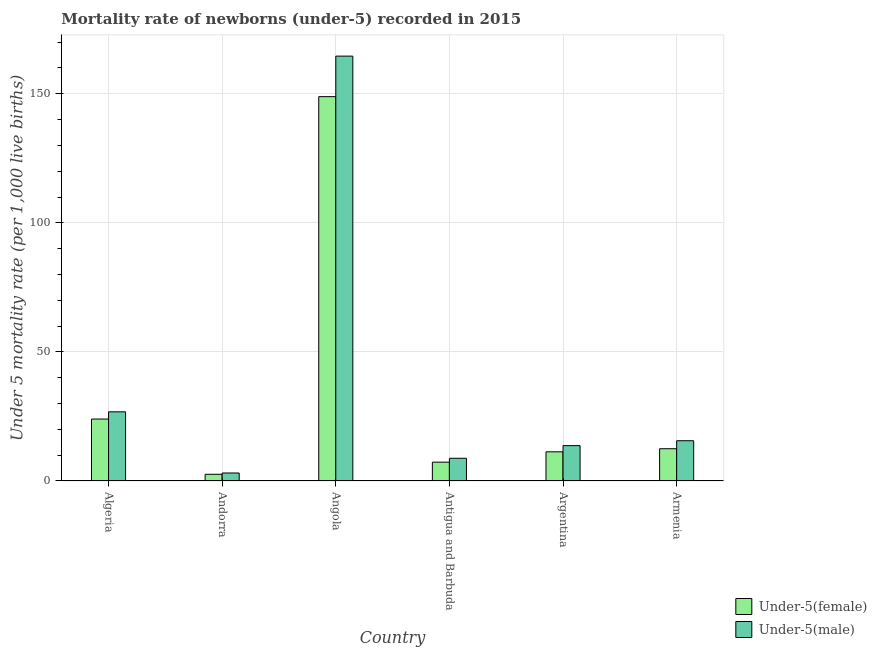Are the number of bars per tick equal to the number of legend labels?
Provide a short and direct response. Yes. Are the number of bars on each tick of the X-axis equal?
Your answer should be compact. Yes. How many bars are there on the 4th tick from the right?
Give a very brief answer. 2. What is the label of the 6th group of bars from the left?
Keep it short and to the point. Armenia. What is the under-5 female mortality rate in Angola?
Your response must be concise. 148.9. Across all countries, what is the maximum under-5 male mortality rate?
Your answer should be compact. 164.6. In which country was the under-5 male mortality rate maximum?
Ensure brevity in your answer.  Angola. In which country was the under-5 female mortality rate minimum?
Your response must be concise. Andorra. What is the total under-5 female mortality rate in the graph?
Your response must be concise. 206.6. What is the difference between the under-5 female mortality rate in Antigua and Barbuda and the under-5 male mortality rate in Andorra?
Your answer should be very brief. 4.2. What is the average under-5 male mortality rate per country?
Your response must be concise. 38.77. What is the difference between the under-5 female mortality rate and under-5 male mortality rate in Armenia?
Ensure brevity in your answer.  -3.1. What is the ratio of the under-5 female mortality rate in Algeria to that in Angola?
Offer a very short reply. 0.16. What is the difference between the highest and the second highest under-5 male mortality rate?
Offer a terse response. 137.8. What is the difference between the highest and the lowest under-5 female mortality rate?
Offer a terse response. 146.3. What does the 2nd bar from the left in Antigua and Barbuda represents?
Give a very brief answer. Under-5(male). What does the 2nd bar from the right in Antigua and Barbuda represents?
Offer a terse response. Under-5(female). Are all the bars in the graph horizontal?
Offer a terse response. No. What is the difference between two consecutive major ticks on the Y-axis?
Keep it short and to the point. 50. Are the values on the major ticks of Y-axis written in scientific E-notation?
Offer a very short reply. No. How many legend labels are there?
Ensure brevity in your answer.  2. What is the title of the graph?
Your answer should be compact. Mortality rate of newborns (under-5) recorded in 2015. What is the label or title of the X-axis?
Your answer should be compact. Country. What is the label or title of the Y-axis?
Keep it short and to the point. Under 5 mortality rate (per 1,0 live births). What is the Under 5 mortality rate (per 1,000 live births) of Under-5(female) in Algeria?
Provide a succinct answer. 24. What is the Under 5 mortality rate (per 1,000 live births) of Under-5(male) in Algeria?
Offer a very short reply. 26.8. What is the Under 5 mortality rate (per 1,000 live births) in Under-5(female) in Andorra?
Offer a terse response. 2.6. What is the Under 5 mortality rate (per 1,000 live births) in Under-5(female) in Angola?
Provide a short and direct response. 148.9. What is the Under 5 mortality rate (per 1,000 live births) of Under-5(male) in Angola?
Give a very brief answer. 164.6. What is the Under 5 mortality rate (per 1,000 live births) in Under-5(female) in Antigua and Barbuda?
Make the answer very short. 7.3. Across all countries, what is the maximum Under 5 mortality rate (per 1,000 live births) of Under-5(female)?
Provide a succinct answer. 148.9. Across all countries, what is the maximum Under 5 mortality rate (per 1,000 live births) of Under-5(male)?
Make the answer very short. 164.6. Across all countries, what is the minimum Under 5 mortality rate (per 1,000 live births) in Under-5(female)?
Provide a succinct answer. 2.6. Across all countries, what is the minimum Under 5 mortality rate (per 1,000 live births) of Under-5(male)?
Keep it short and to the point. 3.1. What is the total Under 5 mortality rate (per 1,000 live births) in Under-5(female) in the graph?
Your response must be concise. 206.6. What is the total Under 5 mortality rate (per 1,000 live births) in Under-5(male) in the graph?
Your answer should be compact. 232.6. What is the difference between the Under 5 mortality rate (per 1,000 live births) in Under-5(female) in Algeria and that in Andorra?
Your response must be concise. 21.4. What is the difference between the Under 5 mortality rate (per 1,000 live births) in Under-5(male) in Algeria and that in Andorra?
Keep it short and to the point. 23.7. What is the difference between the Under 5 mortality rate (per 1,000 live births) of Under-5(female) in Algeria and that in Angola?
Your response must be concise. -124.9. What is the difference between the Under 5 mortality rate (per 1,000 live births) in Under-5(male) in Algeria and that in Angola?
Offer a terse response. -137.8. What is the difference between the Under 5 mortality rate (per 1,000 live births) of Under-5(male) in Algeria and that in Argentina?
Offer a terse response. 13.1. What is the difference between the Under 5 mortality rate (per 1,000 live births) of Under-5(female) in Algeria and that in Armenia?
Keep it short and to the point. 11.5. What is the difference between the Under 5 mortality rate (per 1,000 live births) in Under-5(female) in Andorra and that in Angola?
Your answer should be very brief. -146.3. What is the difference between the Under 5 mortality rate (per 1,000 live births) in Under-5(male) in Andorra and that in Angola?
Make the answer very short. -161.5. What is the difference between the Under 5 mortality rate (per 1,000 live births) of Under-5(female) in Andorra and that in Antigua and Barbuda?
Offer a very short reply. -4.7. What is the difference between the Under 5 mortality rate (per 1,000 live births) in Under-5(male) in Andorra and that in Antigua and Barbuda?
Your answer should be very brief. -5.7. What is the difference between the Under 5 mortality rate (per 1,000 live births) of Under-5(female) in Andorra and that in Armenia?
Offer a terse response. -9.9. What is the difference between the Under 5 mortality rate (per 1,000 live births) in Under-5(male) in Andorra and that in Armenia?
Ensure brevity in your answer.  -12.5. What is the difference between the Under 5 mortality rate (per 1,000 live births) of Under-5(female) in Angola and that in Antigua and Barbuda?
Your response must be concise. 141.6. What is the difference between the Under 5 mortality rate (per 1,000 live births) of Under-5(male) in Angola and that in Antigua and Barbuda?
Ensure brevity in your answer.  155.8. What is the difference between the Under 5 mortality rate (per 1,000 live births) in Under-5(female) in Angola and that in Argentina?
Provide a short and direct response. 137.6. What is the difference between the Under 5 mortality rate (per 1,000 live births) in Under-5(male) in Angola and that in Argentina?
Your answer should be compact. 150.9. What is the difference between the Under 5 mortality rate (per 1,000 live births) of Under-5(female) in Angola and that in Armenia?
Provide a succinct answer. 136.4. What is the difference between the Under 5 mortality rate (per 1,000 live births) in Under-5(male) in Angola and that in Armenia?
Your answer should be compact. 149. What is the difference between the Under 5 mortality rate (per 1,000 live births) of Under-5(male) in Antigua and Barbuda and that in Argentina?
Provide a short and direct response. -4.9. What is the difference between the Under 5 mortality rate (per 1,000 live births) of Under-5(female) in Antigua and Barbuda and that in Armenia?
Give a very brief answer. -5.2. What is the difference between the Under 5 mortality rate (per 1,000 live births) of Under-5(male) in Argentina and that in Armenia?
Your answer should be compact. -1.9. What is the difference between the Under 5 mortality rate (per 1,000 live births) of Under-5(female) in Algeria and the Under 5 mortality rate (per 1,000 live births) of Under-5(male) in Andorra?
Your response must be concise. 20.9. What is the difference between the Under 5 mortality rate (per 1,000 live births) in Under-5(female) in Algeria and the Under 5 mortality rate (per 1,000 live births) in Under-5(male) in Angola?
Your answer should be very brief. -140.6. What is the difference between the Under 5 mortality rate (per 1,000 live births) in Under-5(female) in Algeria and the Under 5 mortality rate (per 1,000 live births) in Under-5(male) in Antigua and Barbuda?
Ensure brevity in your answer.  15.2. What is the difference between the Under 5 mortality rate (per 1,000 live births) in Under-5(female) in Algeria and the Under 5 mortality rate (per 1,000 live births) in Under-5(male) in Armenia?
Ensure brevity in your answer.  8.4. What is the difference between the Under 5 mortality rate (per 1,000 live births) in Under-5(female) in Andorra and the Under 5 mortality rate (per 1,000 live births) in Under-5(male) in Angola?
Your answer should be very brief. -162. What is the difference between the Under 5 mortality rate (per 1,000 live births) of Under-5(female) in Andorra and the Under 5 mortality rate (per 1,000 live births) of Under-5(male) in Antigua and Barbuda?
Provide a short and direct response. -6.2. What is the difference between the Under 5 mortality rate (per 1,000 live births) of Under-5(female) in Andorra and the Under 5 mortality rate (per 1,000 live births) of Under-5(male) in Armenia?
Keep it short and to the point. -13. What is the difference between the Under 5 mortality rate (per 1,000 live births) of Under-5(female) in Angola and the Under 5 mortality rate (per 1,000 live births) of Under-5(male) in Antigua and Barbuda?
Make the answer very short. 140.1. What is the difference between the Under 5 mortality rate (per 1,000 live births) of Under-5(female) in Angola and the Under 5 mortality rate (per 1,000 live births) of Under-5(male) in Argentina?
Your response must be concise. 135.2. What is the difference between the Under 5 mortality rate (per 1,000 live births) of Under-5(female) in Angola and the Under 5 mortality rate (per 1,000 live births) of Under-5(male) in Armenia?
Provide a short and direct response. 133.3. What is the difference between the Under 5 mortality rate (per 1,000 live births) in Under-5(female) in Argentina and the Under 5 mortality rate (per 1,000 live births) in Under-5(male) in Armenia?
Your response must be concise. -4.3. What is the average Under 5 mortality rate (per 1,000 live births) of Under-5(female) per country?
Keep it short and to the point. 34.43. What is the average Under 5 mortality rate (per 1,000 live births) of Under-5(male) per country?
Keep it short and to the point. 38.77. What is the difference between the Under 5 mortality rate (per 1,000 live births) of Under-5(female) and Under 5 mortality rate (per 1,000 live births) of Under-5(male) in Angola?
Offer a terse response. -15.7. What is the difference between the Under 5 mortality rate (per 1,000 live births) of Under-5(female) and Under 5 mortality rate (per 1,000 live births) of Under-5(male) in Armenia?
Provide a short and direct response. -3.1. What is the ratio of the Under 5 mortality rate (per 1,000 live births) in Under-5(female) in Algeria to that in Andorra?
Your answer should be very brief. 9.23. What is the ratio of the Under 5 mortality rate (per 1,000 live births) in Under-5(male) in Algeria to that in Andorra?
Provide a short and direct response. 8.65. What is the ratio of the Under 5 mortality rate (per 1,000 live births) of Under-5(female) in Algeria to that in Angola?
Your response must be concise. 0.16. What is the ratio of the Under 5 mortality rate (per 1,000 live births) of Under-5(male) in Algeria to that in Angola?
Offer a very short reply. 0.16. What is the ratio of the Under 5 mortality rate (per 1,000 live births) in Under-5(female) in Algeria to that in Antigua and Barbuda?
Provide a succinct answer. 3.29. What is the ratio of the Under 5 mortality rate (per 1,000 live births) of Under-5(male) in Algeria to that in Antigua and Barbuda?
Make the answer very short. 3.05. What is the ratio of the Under 5 mortality rate (per 1,000 live births) of Under-5(female) in Algeria to that in Argentina?
Keep it short and to the point. 2.12. What is the ratio of the Under 5 mortality rate (per 1,000 live births) in Under-5(male) in Algeria to that in Argentina?
Make the answer very short. 1.96. What is the ratio of the Under 5 mortality rate (per 1,000 live births) in Under-5(female) in Algeria to that in Armenia?
Ensure brevity in your answer.  1.92. What is the ratio of the Under 5 mortality rate (per 1,000 live births) of Under-5(male) in Algeria to that in Armenia?
Your answer should be compact. 1.72. What is the ratio of the Under 5 mortality rate (per 1,000 live births) of Under-5(female) in Andorra to that in Angola?
Make the answer very short. 0.02. What is the ratio of the Under 5 mortality rate (per 1,000 live births) in Under-5(male) in Andorra to that in Angola?
Provide a succinct answer. 0.02. What is the ratio of the Under 5 mortality rate (per 1,000 live births) of Under-5(female) in Andorra to that in Antigua and Barbuda?
Your answer should be compact. 0.36. What is the ratio of the Under 5 mortality rate (per 1,000 live births) in Under-5(male) in Andorra to that in Antigua and Barbuda?
Keep it short and to the point. 0.35. What is the ratio of the Under 5 mortality rate (per 1,000 live births) in Under-5(female) in Andorra to that in Argentina?
Your answer should be compact. 0.23. What is the ratio of the Under 5 mortality rate (per 1,000 live births) of Under-5(male) in Andorra to that in Argentina?
Offer a terse response. 0.23. What is the ratio of the Under 5 mortality rate (per 1,000 live births) of Under-5(female) in Andorra to that in Armenia?
Your answer should be very brief. 0.21. What is the ratio of the Under 5 mortality rate (per 1,000 live births) in Under-5(male) in Andorra to that in Armenia?
Keep it short and to the point. 0.2. What is the ratio of the Under 5 mortality rate (per 1,000 live births) in Under-5(female) in Angola to that in Antigua and Barbuda?
Keep it short and to the point. 20.4. What is the ratio of the Under 5 mortality rate (per 1,000 live births) in Under-5(male) in Angola to that in Antigua and Barbuda?
Give a very brief answer. 18.7. What is the ratio of the Under 5 mortality rate (per 1,000 live births) in Under-5(female) in Angola to that in Argentina?
Your answer should be compact. 13.18. What is the ratio of the Under 5 mortality rate (per 1,000 live births) in Under-5(male) in Angola to that in Argentina?
Your response must be concise. 12.01. What is the ratio of the Under 5 mortality rate (per 1,000 live births) in Under-5(female) in Angola to that in Armenia?
Provide a succinct answer. 11.91. What is the ratio of the Under 5 mortality rate (per 1,000 live births) in Under-5(male) in Angola to that in Armenia?
Provide a succinct answer. 10.55. What is the ratio of the Under 5 mortality rate (per 1,000 live births) in Under-5(female) in Antigua and Barbuda to that in Argentina?
Give a very brief answer. 0.65. What is the ratio of the Under 5 mortality rate (per 1,000 live births) in Under-5(male) in Antigua and Barbuda to that in Argentina?
Your answer should be very brief. 0.64. What is the ratio of the Under 5 mortality rate (per 1,000 live births) in Under-5(female) in Antigua and Barbuda to that in Armenia?
Provide a succinct answer. 0.58. What is the ratio of the Under 5 mortality rate (per 1,000 live births) in Under-5(male) in Antigua and Barbuda to that in Armenia?
Offer a very short reply. 0.56. What is the ratio of the Under 5 mortality rate (per 1,000 live births) of Under-5(female) in Argentina to that in Armenia?
Provide a short and direct response. 0.9. What is the ratio of the Under 5 mortality rate (per 1,000 live births) of Under-5(male) in Argentina to that in Armenia?
Give a very brief answer. 0.88. What is the difference between the highest and the second highest Under 5 mortality rate (per 1,000 live births) of Under-5(female)?
Your answer should be very brief. 124.9. What is the difference between the highest and the second highest Under 5 mortality rate (per 1,000 live births) in Under-5(male)?
Give a very brief answer. 137.8. What is the difference between the highest and the lowest Under 5 mortality rate (per 1,000 live births) in Under-5(female)?
Your answer should be very brief. 146.3. What is the difference between the highest and the lowest Under 5 mortality rate (per 1,000 live births) of Under-5(male)?
Offer a very short reply. 161.5. 